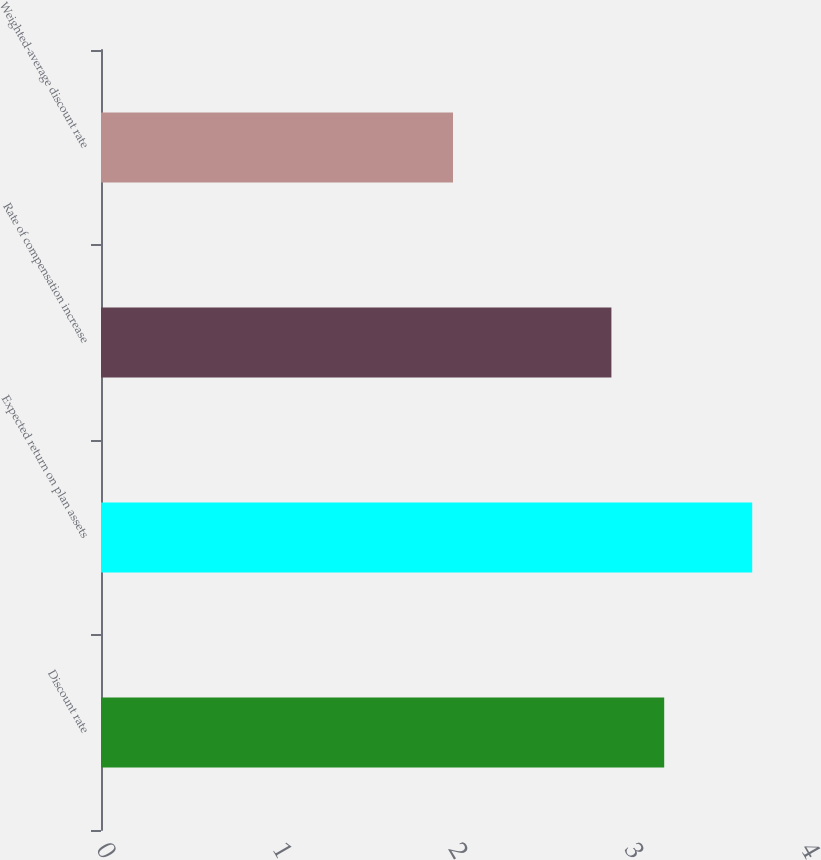<chart> <loc_0><loc_0><loc_500><loc_500><bar_chart><fcel>Discount rate<fcel>Expected return on plan assets<fcel>Rate of compensation increase<fcel>Weighted-average discount rate<nl><fcel>3.2<fcel>3.7<fcel>2.9<fcel>2<nl></chart> 